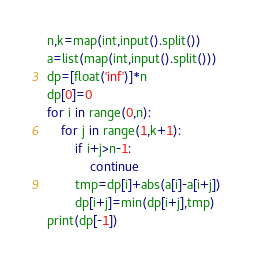<code> <loc_0><loc_0><loc_500><loc_500><_Python_>n,k=map(int,input().split())
a=list(map(int,input().split()))
dp=[float('inf')]*n
dp[0]=0
for i in range(0,n):
    for j in range(1,k+1):
        if i+j>n-1:
            continue
        tmp=dp[i]+abs(a[i]-a[i+j])
        dp[i+j]=min(dp[i+j],tmp)
print(dp[-1])</code> 